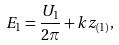Convert formula to latex. <formula><loc_0><loc_0><loc_500><loc_500>E _ { 1 } = \frac { U _ { 1 } } { 2 \pi } + k z _ { ( 1 ) } ,</formula> 